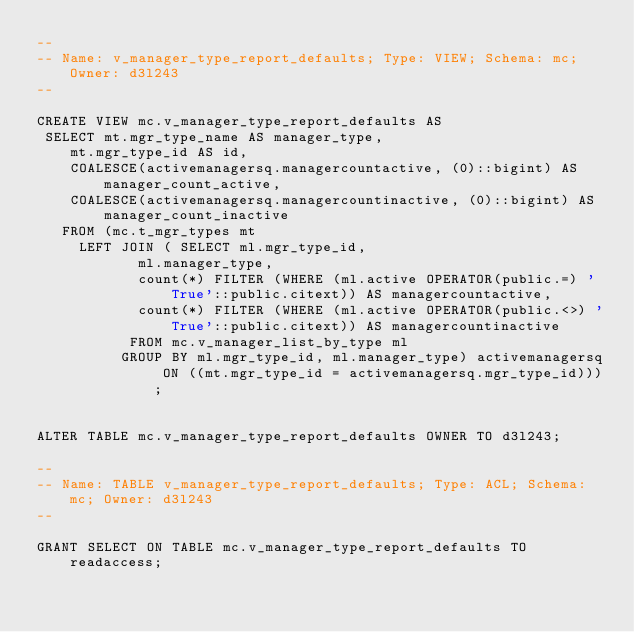Convert code to text. <code><loc_0><loc_0><loc_500><loc_500><_SQL_>--
-- Name: v_manager_type_report_defaults; Type: VIEW; Schema: mc; Owner: d3l243
--

CREATE VIEW mc.v_manager_type_report_defaults AS
 SELECT mt.mgr_type_name AS manager_type,
    mt.mgr_type_id AS id,
    COALESCE(activemanagersq.managercountactive, (0)::bigint) AS manager_count_active,
    COALESCE(activemanagersq.managercountinactive, (0)::bigint) AS manager_count_inactive
   FROM (mc.t_mgr_types mt
     LEFT JOIN ( SELECT ml.mgr_type_id,
            ml.manager_type,
            count(*) FILTER (WHERE (ml.active OPERATOR(public.=) 'True'::public.citext)) AS managercountactive,
            count(*) FILTER (WHERE (ml.active OPERATOR(public.<>) 'True'::public.citext)) AS managercountinactive
           FROM mc.v_manager_list_by_type ml
          GROUP BY ml.mgr_type_id, ml.manager_type) activemanagersq ON ((mt.mgr_type_id = activemanagersq.mgr_type_id)));


ALTER TABLE mc.v_manager_type_report_defaults OWNER TO d3l243;

--
-- Name: TABLE v_manager_type_report_defaults; Type: ACL; Schema: mc; Owner: d3l243
--

GRANT SELECT ON TABLE mc.v_manager_type_report_defaults TO readaccess;

</code> 